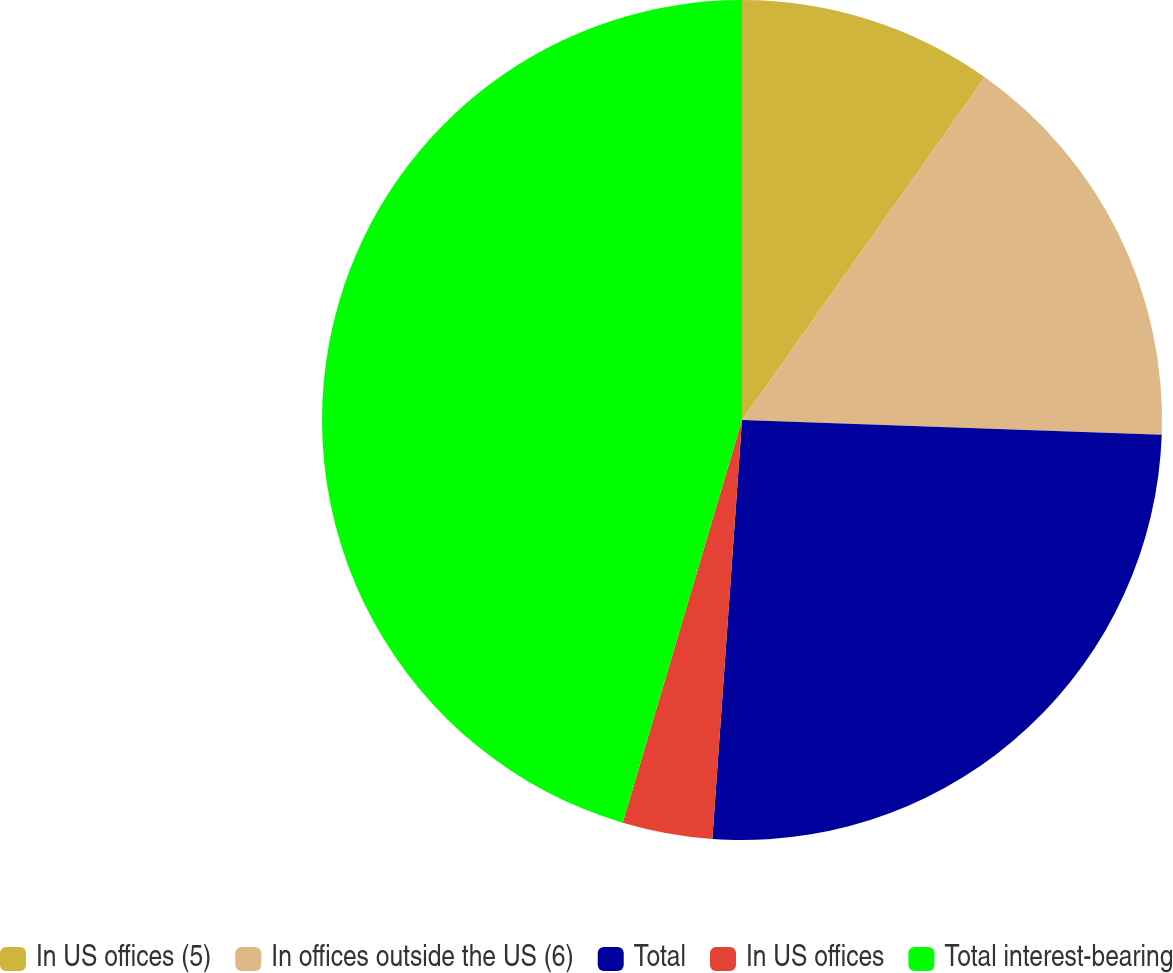<chart> <loc_0><loc_0><loc_500><loc_500><pie_chart><fcel>In US offices (5)<fcel>In offices outside the US (6)<fcel>Total<fcel>In US offices<fcel>Total interest-bearing<nl><fcel>9.81%<fcel>15.75%<fcel>25.56%<fcel>3.46%<fcel>45.41%<nl></chart> 